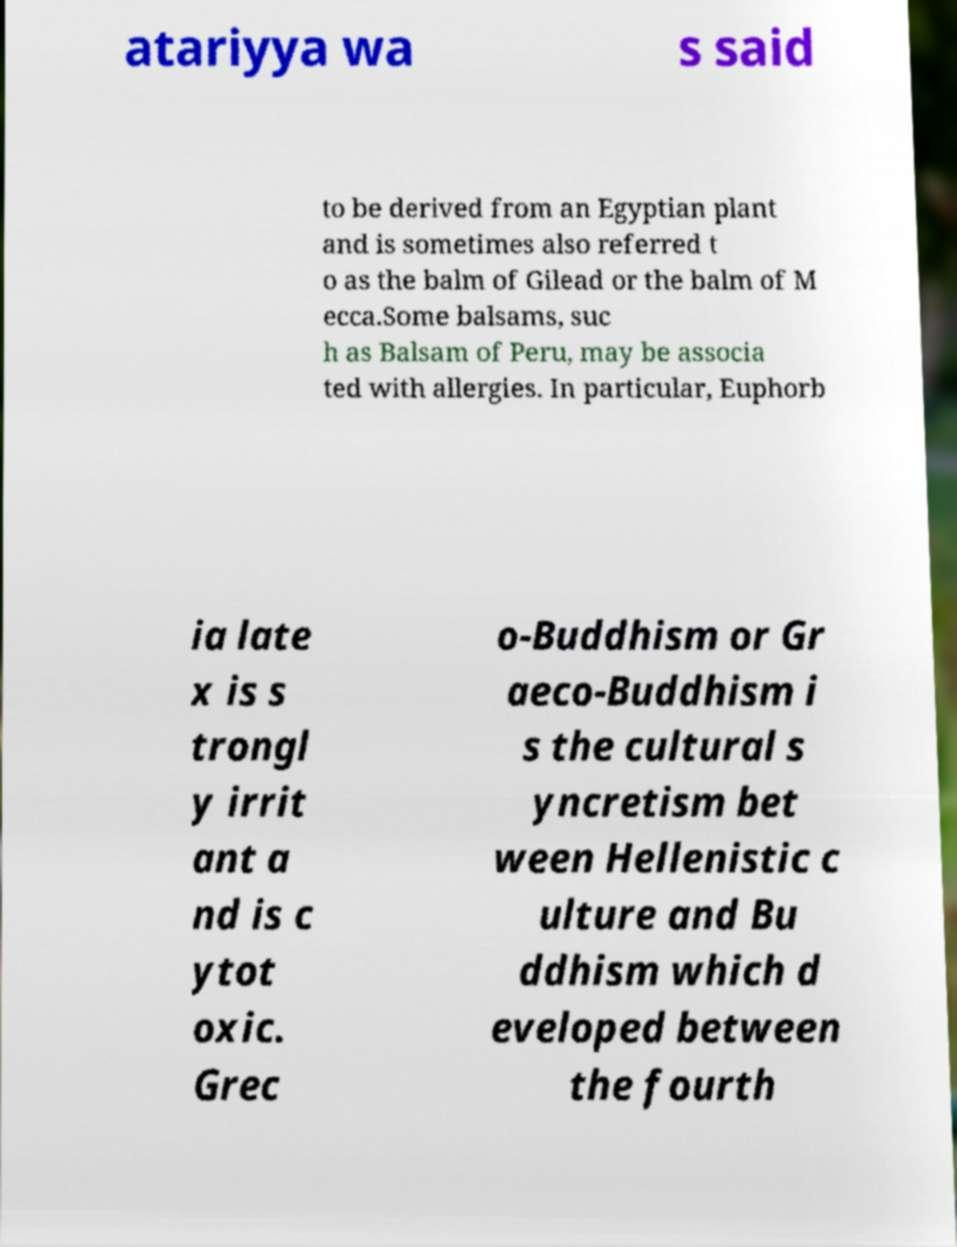For documentation purposes, I need the text within this image transcribed. Could you provide that? atariyya wa s said to be derived from an Egyptian plant and is sometimes also referred t o as the balm of Gilead or the balm of M ecca.Some balsams, suc h as Balsam of Peru, may be associa ted with allergies. In particular, Euphorb ia late x is s trongl y irrit ant a nd is c ytot oxic. Grec o-Buddhism or Gr aeco-Buddhism i s the cultural s yncretism bet ween Hellenistic c ulture and Bu ddhism which d eveloped between the fourth 